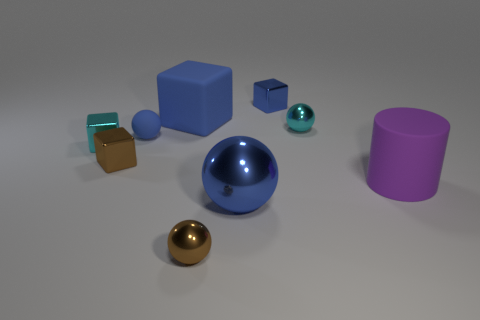Subtract all purple spheres. Subtract all purple cylinders. How many spheres are left? 4 Subtract all spheres. How many objects are left? 5 Subtract 1 purple cylinders. How many objects are left? 8 Subtract all purple matte cylinders. Subtract all small blocks. How many objects are left? 5 Add 4 big purple matte objects. How many big purple matte objects are left? 5 Add 3 brown metal blocks. How many brown metal blocks exist? 4 